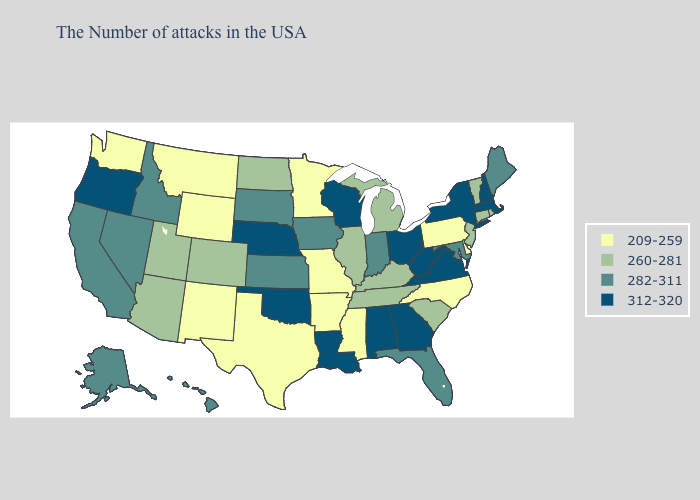What is the lowest value in the USA?
Be succinct. 209-259. Name the states that have a value in the range 282-311?
Concise answer only. Maine, Maryland, Florida, Indiana, Iowa, Kansas, South Dakota, Idaho, Nevada, California, Alaska, Hawaii. Name the states that have a value in the range 282-311?
Short answer required. Maine, Maryland, Florida, Indiana, Iowa, Kansas, South Dakota, Idaho, Nevada, California, Alaska, Hawaii. Among the states that border Rhode Island , does Connecticut have the lowest value?
Quick response, please. Yes. What is the value of Oregon?
Concise answer only. 312-320. What is the highest value in the South ?
Be succinct. 312-320. Among the states that border New York , does New Jersey have the highest value?
Quick response, please. No. What is the highest value in states that border North Dakota?
Be succinct. 282-311. How many symbols are there in the legend?
Quick response, please. 4. What is the highest value in states that border Missouri?
Concise answer only. 312-320. What is the value of Texas?
Be succinct. 209-259. Which states hav the highest value in the MidWest?
Short answer required. Ohio, Wisconsin, Nebraska. Does the first symbol in the legend represent the smallest category?
Write a very short answer. Yes. Name the states that have a value in the range 282-311?
Write a very short answer. Maine, Maryland, Florida, Indiana, Iowa, Kansas, South Dakota, Idaho, Nevada, California, Alaska, Hawaii. What is the highest value in states that border Oklahoma?
Be succinct. 282-311. 